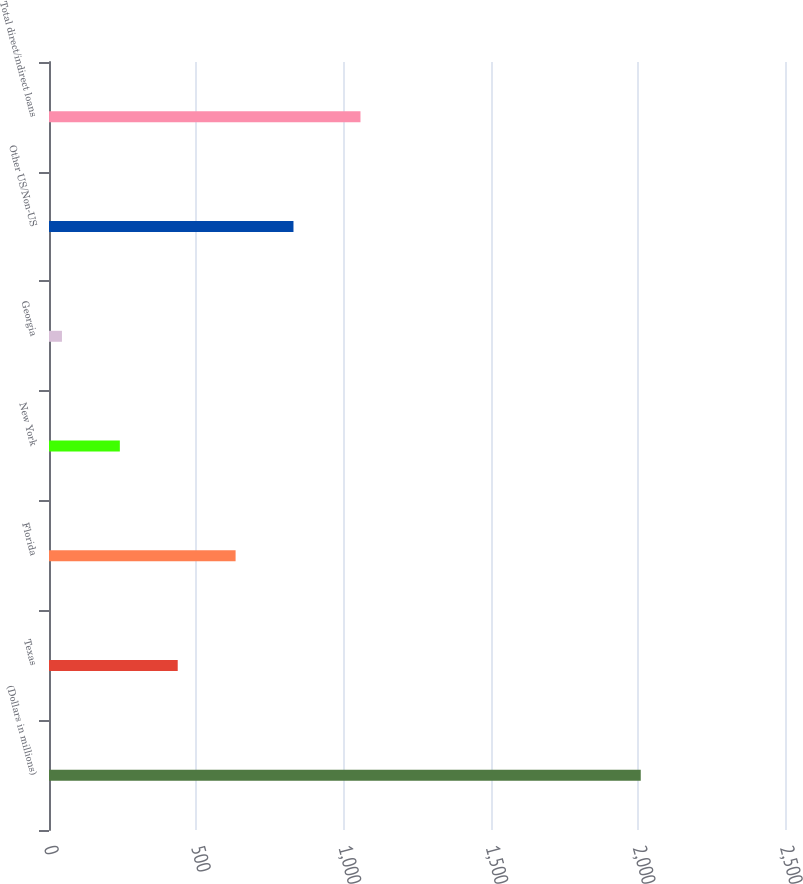<chart> <loc_0><loc_0><loc_500><loc_500><bar_chart><fcel>(Dollars in millions)<fcel>Texas<fcel>Florida<fcel>New York<fcel>Georgia<fcel>Other US/Non-US<fcel>Total direct/indirect loans<nl><fcel>2010<fcel>437.2<fcel>633.8<fcel>240.6<fcel>44<fcel>830.4<fcel>1058<nl></chart> 